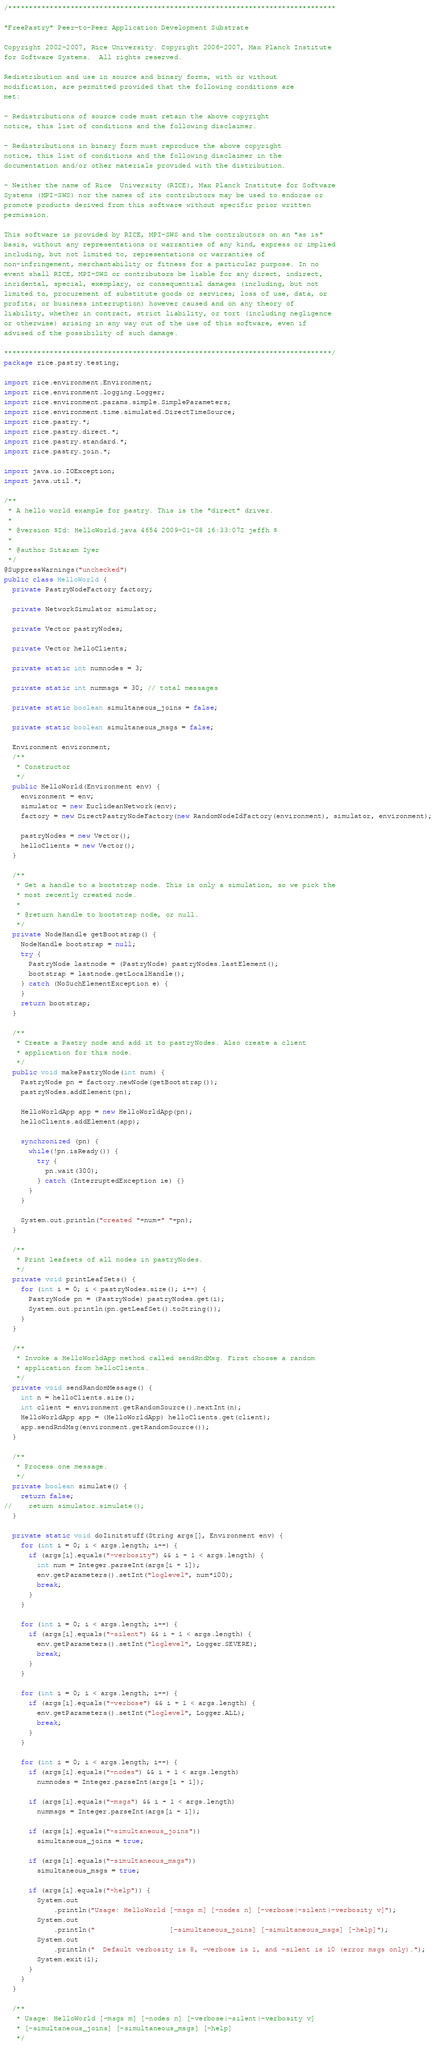Convert code to text. <code><loc_0><loc_0><loc_500><loc_500><_Java_>/*******************************************************************************

"FreePastry" Peer-to-Peer Application Development Substrate

Copyright 2002-2007, Rice University. Copyright 2006-2007, Max Planck Institute 
for Software Systems.  All rights reserved.

Redistribution and use in source and binary forms, with or without
modification, are permitted provided that the following conditions are
met:

- Redistributions of source code must retain the above copyright
notice, this list of conditions and the following disclaimer.

- Redistributions in binary form must reproduce the above copyright
notice, this list of conditions and the following disclaimer in the
documentation and/or other materials provided with the distribution.

- Neither the name of Rice  University (RICE), Max Planck Institute for Software 
Systems (MPI-SWS) nor the names of its contributors may be used to endorse or 
promote products derived from this software without specific prior written 
permission.

This software is provided by RICE, MPI-SWS and the contributors on an "as is" 
basis, without any representations or warranties of any kind, express or implied 
including, but not limited to, representations or warranties of 
non-infringement, merchantability or fitness for a particular purpose. In no 
event shall RICE, MPI-SWS or contributors be liable for any direct, indirect, 
incidental, special, exemplary, or consequential damages (including, but not 
limited to, procurement of substitute goods or services; loss of use, data, or 
profits; or business interruption) however caused and on any theory of 
liability, whether in contract, strict liability, or tort (including negligence
or otherwise) arising in any way out of the use of this software, even if 
advised of the possibility of such damage.

*******************************************************************************/ 
package rice.pastry.testing;

import rice.environment.Environment;
import rice.environment.logging.Logger;
import rice.environment.params.simple.SimpleParameters;
import rice.environment.time.simulated.DirectTimeSource;
import rice.pastry.*;
import rice.pastry.direct.*;
import rice.pastry.standard.*;
import rice.pastry.join.*;

import java.io.IOException;
import java.util.*;

/**
 * A hello world example for pastry. This is the "direct" driver.
 * 
 * @version $Id: HelloWorld.java 4654 2009-01-08 16:33:07Z jeffh $
 * 
 * @author Sitaram Iyer
 */
@SuppressWarnings("unchecked")
public class HelloWorld {
  private PastryNodeFactory factory;

  private NetworkSimulator simulator;

  private Vector pastryNodes;

  private Vector helloClients;

  private static int numnodes = 3;

  private static int nummsgs = 30; // total messages

  private static boolean simultaneous_joins = false;

  private static boolean simultaneous_msgs = false;

  Environment environment;
  /**
   * Constructor
   */
  public HelloWorld(Environment env) {
    environment = env;
    simulator = new EuclideanNetwork(env);
    factory = new DirectPastryNodeFactory(new RandomNodeIdFactory(environment), simulator, environment);

    pastryNodes = new Vector();
    helloClients = new Vector();
  }

  /**
   * Get a handle to a bootstrap node. This is only a simulation, so we pick the
   * most recently created node.
   * 
   * @return handle to bootstrap node, or null.
   */
  private NodeHandle getBootstrap() {
    NodeHandle bootstrap = null;
    try {
      PastryNode lastnode = (PastryNode) pastryNodes.lastElement();
      bootstrap = lastnode.getLocalHandle();
    } catch (NoSuchElementException e) {
    }
    return bootstrap;
  }

  /**
   * Create a Pastry node and add it to pastryNodes. Also create a client
   * application for this node.
   */
  public void makePastryNode(int num) {
    PastryNode pn = factory.newNode(getBootstrap());
    pastryNodes.addElement(pn);

    HelloWorldApp app = new HelloWorldApp(pn);
    helloClients.addElement(app);
    
    synchronized (pn) {
      while(!pn.isReady()) {
        try {
          pn.wait(300);
        } catch (InterruptedException ie) {}
      }
    }
    
    System.out.println("created "+num+" "+pn);
  }

  /**
   * Print leafsets of all nodes in pastryNodes.
   */
  private void printLeafSets() {
    for (int i = 0; i < pastryNodes.size(); i++) {
      PastryNode pn = (PastryNode) pastryNodes.get(i);
      System.out.println(pn.getLeafSet().toString());
    }
  }

  /**
   * Invoke a HelloWorldApp method called sendRndMsg. First choose a random
   * application from helloClients.
   */
  private void sendRandomMessage() {
    int n = helloClients.size();
    int client = environment.getRandomSource().nextInt(n);
    HelloWorldApp app = (HelloWorldApp) helloClients.get(client);
    app.sendRndMsg(environment.getRandomSource());
  }

  /**
   * Process one message.
   */
  private boolean simulate() {
    return false;
//    return simulator.simulate();
  }

  private static void doIinitstuff(String args[], Environment env) {
    for (int i = 0; i < args.length; i++) {
      if (args[i].equals("-verbosity") && i + 1 < args.length) {
        int num = Integer.parseInt(args[i + 1]);
        env.getParameters().setInt("loglevel", num*100);
        break;
      }
    }

    for (int i = 0; i < args.length; i++) {
      if (args[i].equals("-silent") && i + 1 < args.length) {
        env.getParameters().setInt("loglevel", Logger.SEVERE);
        break;
      }        
    }

    for (int i = 0; i < args.length; i++) {
      if (args[i].equals("-verbose") && i + 1 < args.length) {
        env.getParameters().setInt("loglevel", Logger.ALL);
        break;
      }        
    }

    for (int i = 0; i < args.length; i++) {
      if (args[i].equals("-nodes") && i + 1 < args.length)
        numnodes = Integer.parseInt(args[i + 1]);

      if (args[i].equals("-msgs") && i + 1 < args.length)
        nummsgs = Integer.parseInt(args[i + 1]);

      if (args[i].equals("-simultaneous_joins"))
        simultaneous_joins = true;

      if (args[i].equals("-simultaneous_msgs"))
        simultaneous_msgs = true;

      if (args[i].equals("-help")) {
        System.out
            .println("Usage: HelloWorld [-msgs m] [-nodes n] [-verbose|-silent|-verbosity v]");        
        System.out
            .println("                  [-simultaneous_joins] [-simultaneous_msgs] [-help]");
        System.out
            .println("  Default verbosity is 8, -verbose is 1, and -silent is 10 (error msgs only).");
        System.exit(1);
      }
    }    
  }
  
  /**
   * Usage: HelloWorld [-msgs m] [-nodes n] [-verbose|-silent|-verbosity v]
   * [-simultaneous_joins] [-simultaneous_msgs] [-help]
   */</code> 